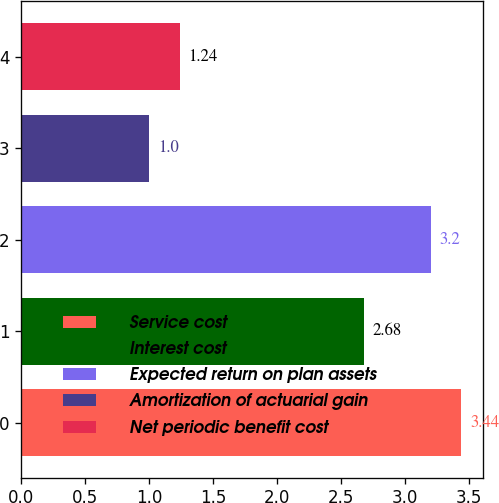Convert chart to OTSL. <chart><loc_0><loc_0><loc_500><loc_500><bar_chart><fcel>Service cost<fcel>Interest cost<fcel>Expected return on plan assets<fcel>Amortization of actuarial gain<fcel>Net periodic benefit cost<nl><fcel>3.44<fcel>2.68<fcel>3.2<fcel>1<fcel>1.24<nl></chart> 